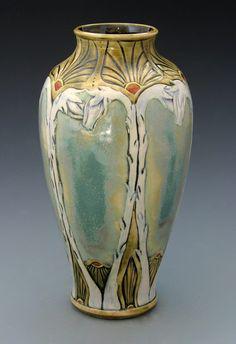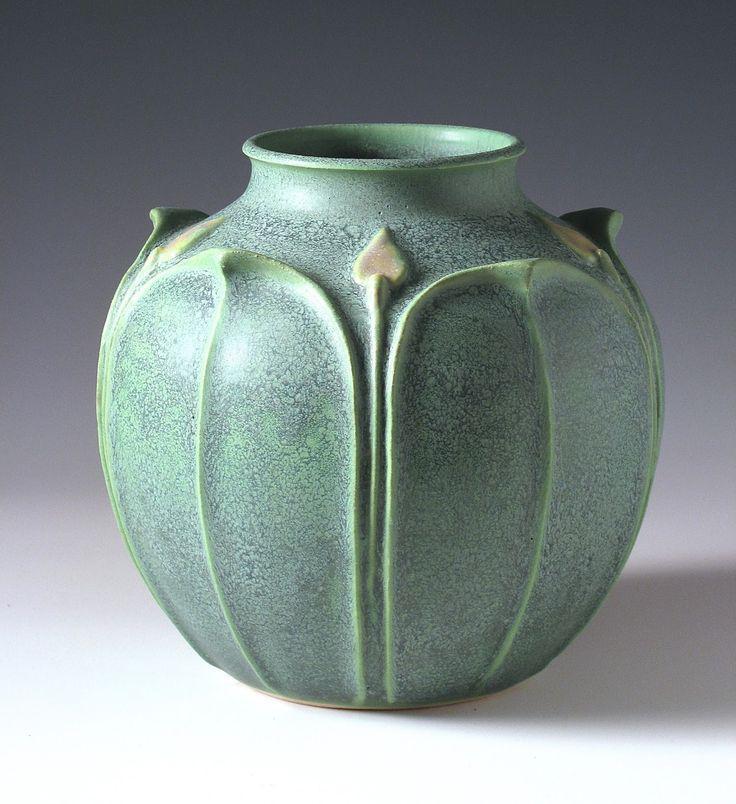The first image is the image on the left, the second image is the image on the right. Assess this claim about the two images: "One of the vases is decorated with an illustrated design from top to bottom and shaped in a way that tapers to a smaller base.". Correct or not? Answer yes or no. Yes. The first image is the image on the left, the second image is the image on the right. Evaluate the accuracy of this statement regarding the images: "In one image, a tall vase has an intricate faded green and yellow design with thin vertical elements running top to bottom, accented with small orange fan shapes.". Is it true? Answer yes or no. Yes. 